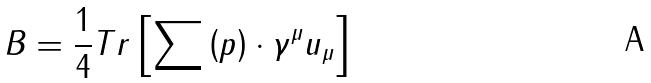<formula> <loc_0><loc_0><loc_500><loc_500>B = \frac { 1 } { 4 } T r \left [ \sum \left ( p \right ) \cdot \gamma ^ { \mu } u _ { \mu } \right ]</formula> 